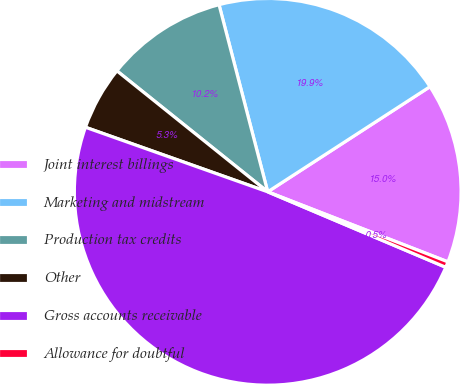Convert chart. <chart><loc_0><loc_0><loc_500><loc_500><pie_chart><fcel>Joint interest billings<fcel>Marketing and midstream<fcel>Production tax credits<fcel>Other<fcel>Gross accounts receivable<fcel>Allowance for doubtful<nl><fcel>15.05%<fcel>19.9%<fcel>10.19%<fcel>5.34%<fcel>49.04%<fcel>0.48%<nl></chart> 